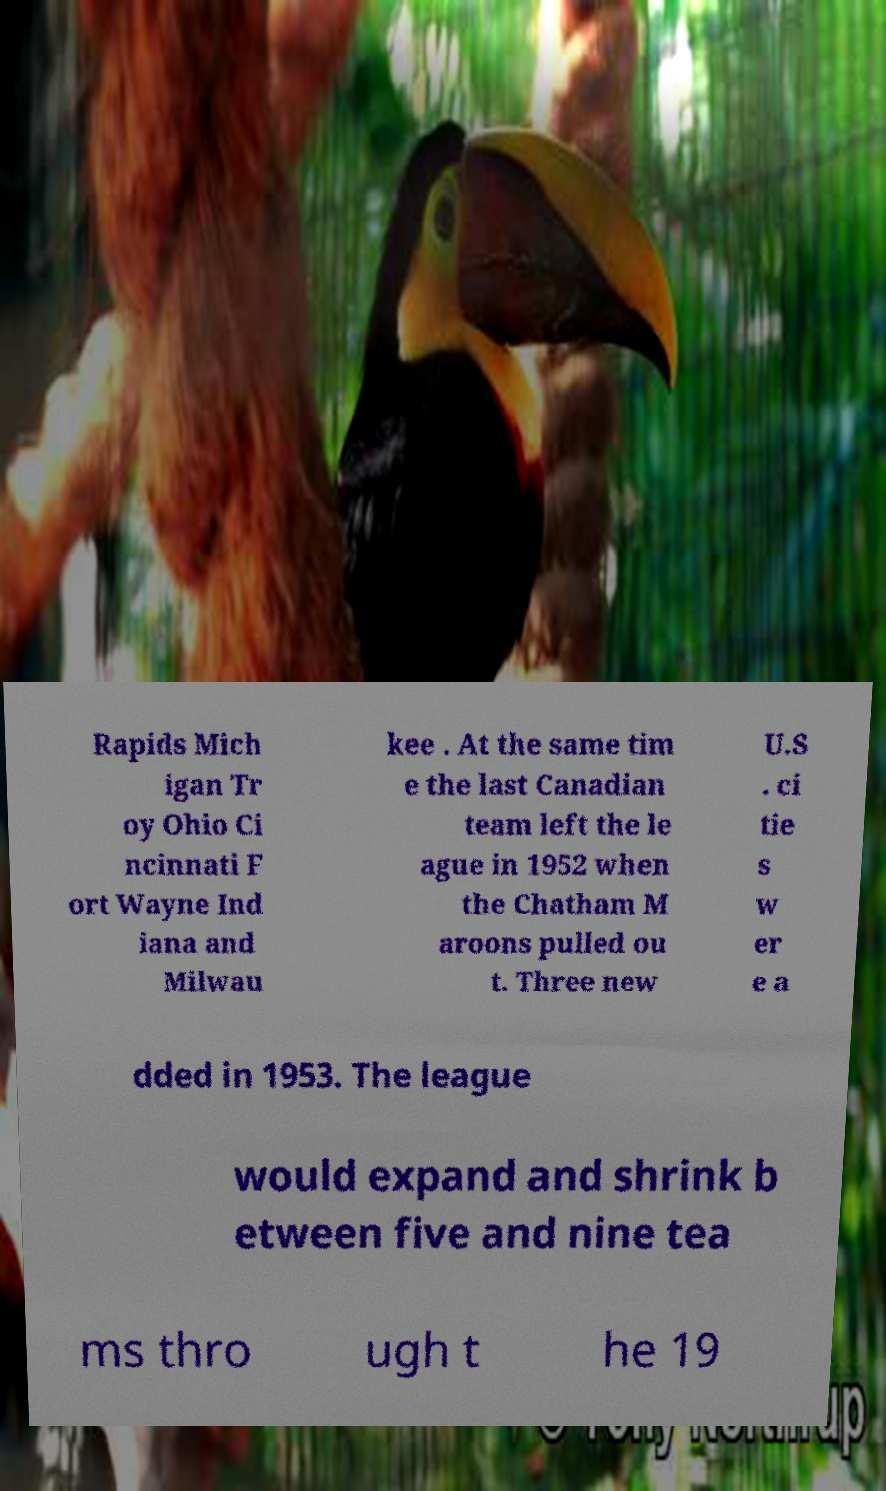Could you extract and type out the text from this image? Rapids Mich igan Tr oy Ohio Ci ncinnati F ort Wayne Ind iana and Milwau kee . At the same tim e the last Canadian team left the le ague in 1952 when the Chatham M aroons pulled ou t. Three new U.S . ci tie s w er e a dded in 1953. The league would expand and shrink b etween five and nine tea ms thro ugh t he 19 